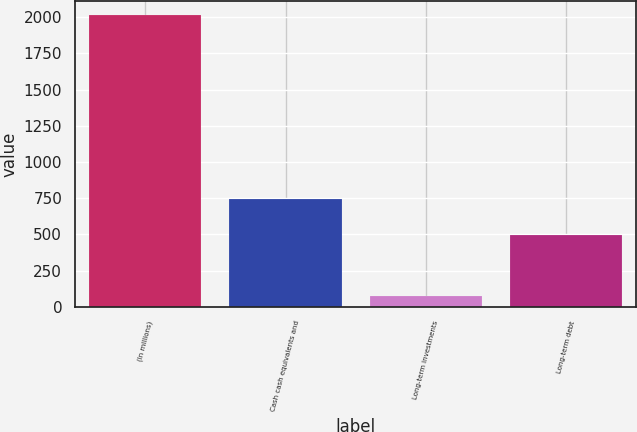<chart> <loc_0><loc_0><loc_500><loc_500><bar_chart><fcel>(In millions)<fcel>Cash cash equivalents and<fcel>Long-term investments<fcel>Long-term debt<nl><fcel>2012<fcel>744<fcel>75<fcel>499<nl></chart> 